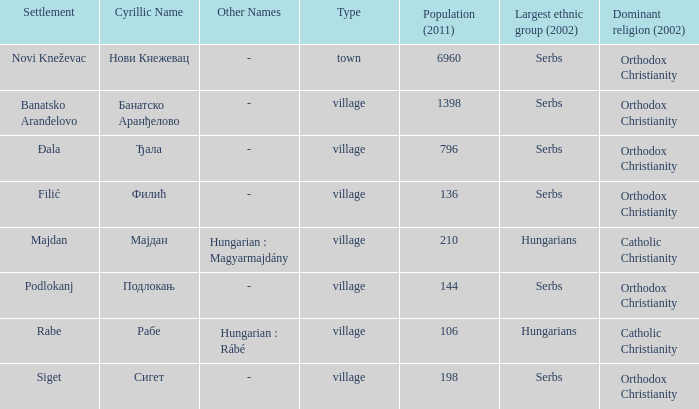What type of settlement is rabe? Village. 